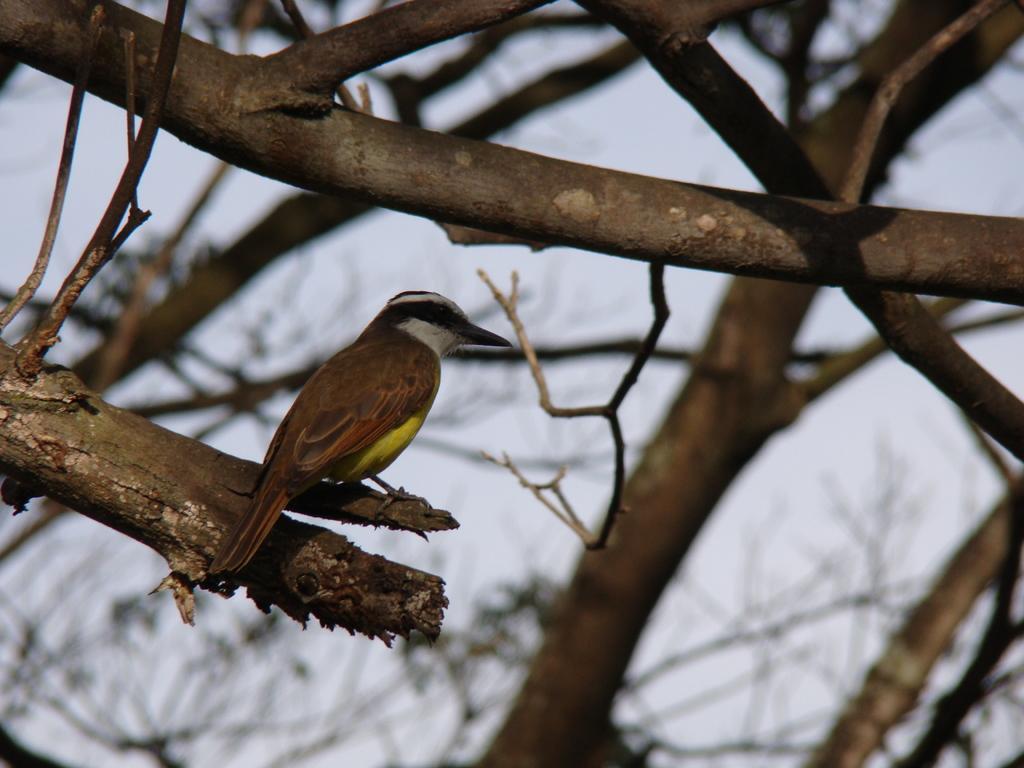What type of animal can be seen in the image? There is a bird in the image. Where is the bird located in the image? The bird is standing on a branch. What colors can be seen on the bird? The bird has brown, yellow, black, and white colors. What is visible in the background of the image? The sky is visible in the image. What color is the sky in the image? The sky is white in color. How many rabbits are hiding under the bird's shade in the image? There are no rabbits or shade present in the image; it features a bird standing on a branch with a white sky in the background. 